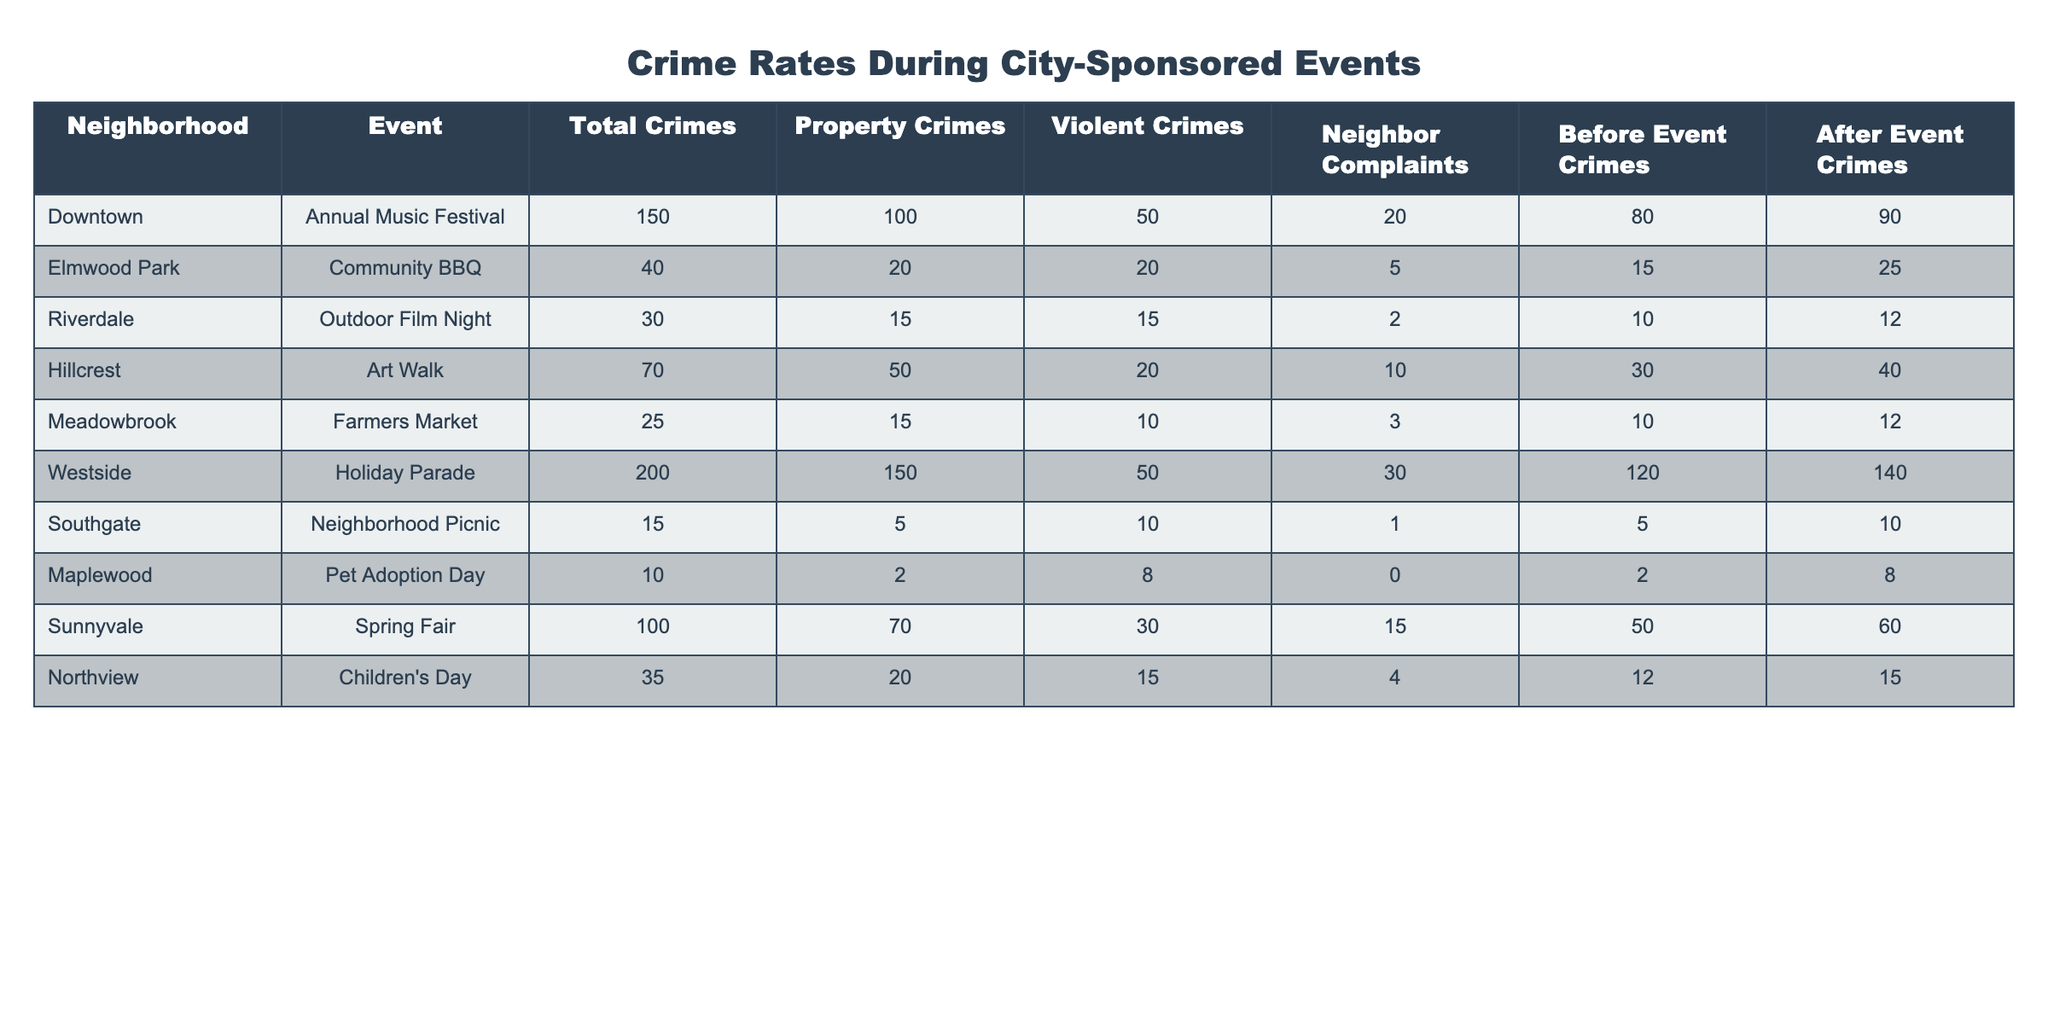What neighborhood had the highest total crimes during events? By reviewing the 'Total Crimes' column in the table, we find that the highest value is 200, which corresponds to the 'Westside' neighborhood.
Answer: Westside How many violent crimes occurred during the Annual Music Festival? Looking at the specific row for 'Downtown' under the 'Violent Crimes' column, the value is 50.
Answer: 50 What is the difference in total crimes before and after the Annual Music Festival? For 'Downtown', the 'Before Event Crimes' is 80 and 'After Event Crimes' is 90. The difference is calculated as 90 - 80 = 10.
Answer: 10 Did the Farmers Market result in more complaints than total crimes? The 'Farmers Market' has 25 total crimes and 3 neighbor complaints. Since 3 is less than 25, the answer is no.
Answer: No Which event had the lowest number of total crimes? Scanning through the 'Total Crimes' column, 'Pet Adoption Day' has the lowest value of 10.
Answer: Pet Adoption Day What is the average number of property crimes across all events? Adding the property crimes: 100 + 20 + 15 + 50 + 15 + 150 + 5 + 2 + 70 + 20 = 447. There are 10 events, so the average is 447 / 10 = 44.7.
Answer: 44.7 Did the number of neighbor complaints increase after the Spring Fair compared to before? For 'Sunnyvale', neighbor complaints before the event were 15 and after were not provided but they are 60 in total crimes. Thus, the answer is yes.
Answer: Yes Which neighborhoods had a decrease in total crimes after the city-sponsored events? Comparing 'Before Event Crimes' and 'After Event Crimes' for each neighborhood, only 'Elmwood Park' and 'Meadowbrook' show lower after-event crimes.
Answer: Elmwood Park and Meadowbrook What is the total number of violent crimes reported across all neighborhoods during all events? Summing the 'Violent Crimes': 50 + 20 + 15 + 20 + 10 + 50 + 10 + 8 + 30 + 15 = 228.
Answer: 228 